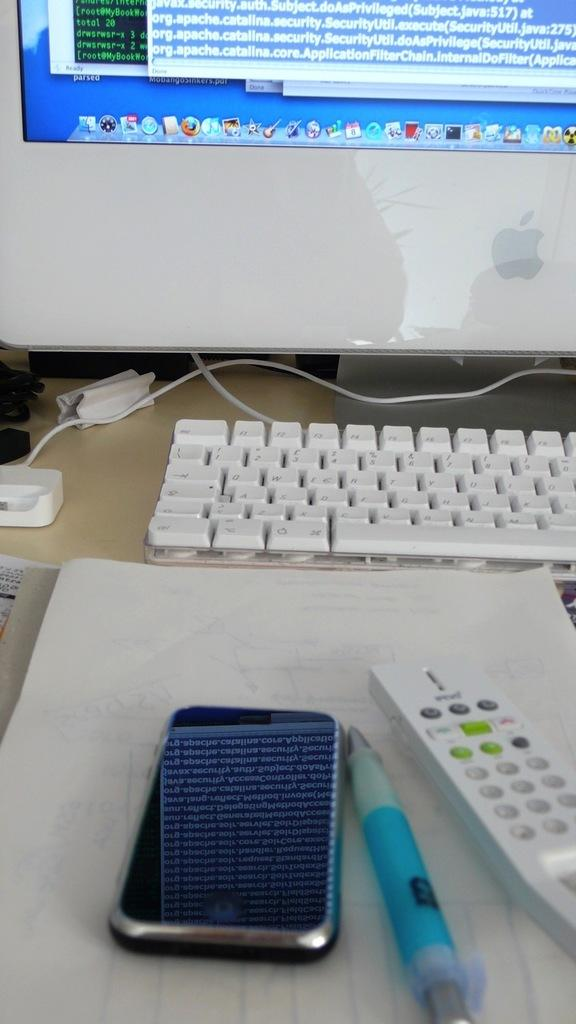<image>
Describe the image concisely. A phone sits next to a pen and a remote control with a monitor that says parsed at the bottom. 